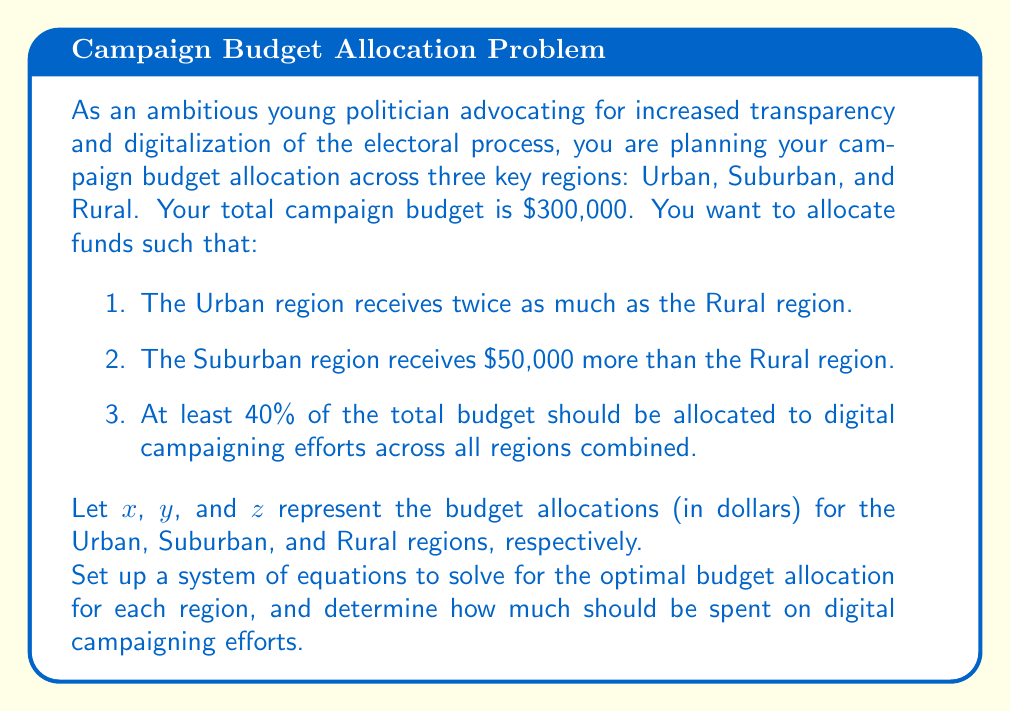Give your solution to this math problem. Let's approach this problem step by step:

1) First, let's set up the system of equations based on the given conditions:

   Total budget: $x + y + z = 300000$ ... (1)
   Urban is twice Rural: $x = 2z$ ... (2)
   Suburban is $50,000 more than Rural: $y = z + 50000$ ... (3)

2) Substitute (2) and (3) into (1):

   $2z + (z + 50000) + z = 300000$
   $4z + 50000 = 300000$
   $4z = 250000$
   $z = 62500$

3) Now we can find $x$ and $y$:

   $x = 2z = 2(62500) = 125000$
   $y = z + 50000 = 62500 + 50000 = 112500$

4) Let's verify that these values satisfy all conditions:

   $x + y + z = 125000 + 112500 + 62500 = 300000$ ✓
   $x = 2z$ : $125000 = 2(62500)$ ✓
   $y = z + 50000$ : $112500 = 62500 + 50000$ ✓

5) For the digital campaigning efforts, we need at least 40% of the total budget:

   $0.4 * 300000 = 120000$

Therefore, at least $120,000 should be allocated to digital campaigning efforts across all regions.
Answer: Urban region (x): $125,000
Suburban region (y): $112,500
Rural region (z): $62,500
Minimum for digital campaigning: $120,000 